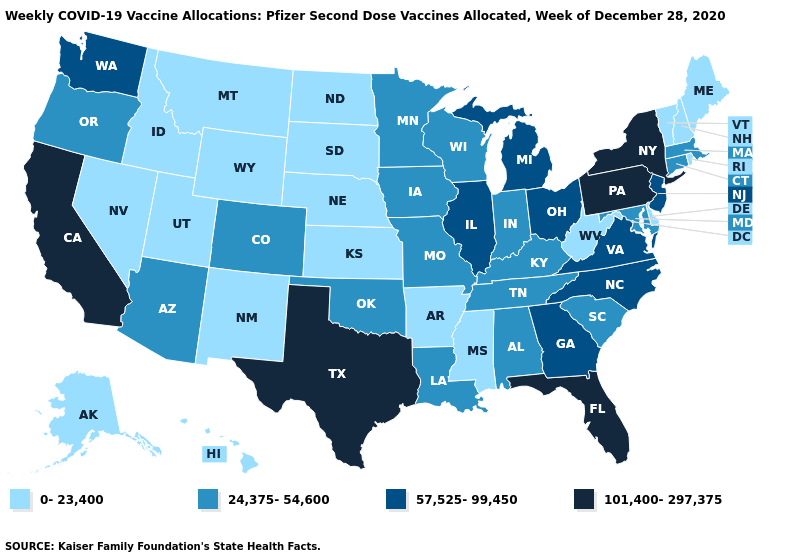Which states have the lowest value in the South?
Concise answer only. Arkansas, Delaware, Mississippi, West Virginia. What is the value of Indiana?
Concise answer only. 24,375-54,600. Which states have the highest value in the USA?
Short answer required. California, Florida, New York, Pennsylvania, Texas. Does Oklahoma have a lower value than Florida?
Write a very short answer. Yes. Among the states that border Georgia , does Tennessee have the highest value?
Answer briefly. No. Does the first symbol in the legend represent the smallest category?
Be succinct. Yes. Does California have the highest value in the West?
Answer briefly. Yes. What is the lowest value in states that border Illinois?
Answer briefly. 24,375-54,600. Does Michigan have a lower value than California?
Concise answer only. Yes. What is the value of West Virginia?
Quick response, please. 0-23,400. Does Washington have the lowest value in the USA?
Answer briefly. No. Name the states that have a value in the range 57,525-99,450?
Give a very brief answer. Georgia, Illinois, Michigan, New Jersey, North Carolina, Ohio, Virginia, Washington. Does Pennsylvania have the same value as New York?
Short answer required. Yes. Which states have the highest value in the USA?
Give a very brief answer. California, Florida, New York, Pennsylvania, Texas. Name the states that have a value in the range 101,400-297,375?
Keep it brief. California, Florida, New York, Pennsylvania, Texas. 